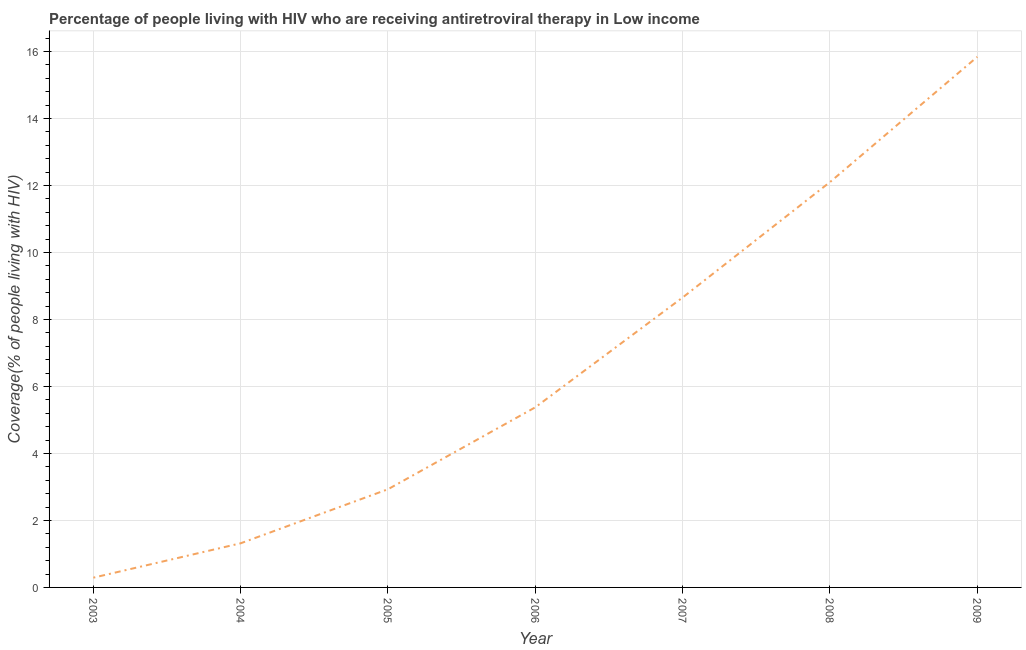What is the antiretroviral therapy coverage in 2003?
Provide a succinct answer. 0.29. Across all years, what is the maximum antiretroviral therapy coverage?
Provide a short and direct response. 15.84. Across all years, what is the minimum antiretroviral therapy coverage?
Keep it short and to the point. 0.29. In which year was the antiretroviral therapy coverage maximum?
Offer a terse response. 2009. In which year was the antiretroviral therapy coverage minimum?
Your answer should be very brief. 2003. What is the sum of the antiretroviral therapy coverage?
Offer a very short reply. 46.52. What is the difference between the antiretroviral therapy coverage in 2003 and 2008?
Your response must be concise. -11.81. What is the average antiretroviral therapy coverage per year?
Your answer should be compact. 6.65. What is the median antiretroviral therapy coverage?
Your answer should be very brief. 5.38. In how many years, is the antiretroviral therapy coverage greater than 4.4 %?
Give a very brief answer. 4. Do a majority of the years between 2005 and 2008 (inclusive) have antiretroviral therapy coverage greater than 3.6 %?
Make the answer very short. Yes. What is the ratio of the antiretroviral therapy coverage in 2003 to that in 2008?
Make the answer very short. 0.02. What is the difference between the highest and the second highest antiretroviral therapy coverage?
Offer a terse response. 3.74. Is the sum of the antiretroviral therapy coverage in 2006 and 2007 greater than the maximum antiretroviral therapy coverage across all years?
Your answer should be very brief. No. What is the difference between the highest and the lowest antiretroviral therapy coverage?
Provide a short and direct response. 15.55. In how many years, is the antiretroviral therapy coverage greater than the average antiretroviral therapy coverage taken over all years?
Ensure brevity in your answer.  3. How many lines are there?
Make the answer very short. 1. How many years are there in the graph?
Give a very brief answer. 7. What is the difference between two consecutive major ticks on the Y-axis?
Your answer should be very brief. 2. Are the values on the major ticks of Y-axis written in scientific E-notation?
Provide a short and direct response. No. Does the graph contain any zero values?
Provide a short and direct response. No. Does the graph contain grids?
Keep it short and to the point. Yes. What is the title of the graph?
Make the answer very short. Percentage of people living with HIV who are receiving antiretroviral therapy in Low income. What is the label or title of the Y-axis?
Offer a terse response. Coverage(% of people living with HIV). What is the Coverage(% of people living with HIV) of 2003?
Provide a short and direct response. 0.29. What is the Coverage(% of people living with HIV) in 2004?
Your response must be concise. 1.32. What is the Coverage(% of people living with HIV) of 2005?
Ensure brevity in your answer.  2.93. What is the Coverage(% of people living with HIV) of 2006?
Provide a short and direct response. 5.38. What is the Coverage(% of people living with HIV) in 2007?
Make the answer very short. 8.66. What is the Coverage(% of people living with HIV) in 2008?
Your answer should be compact. 12.1. What is the Coverage(% of people living with HIV) in 2009?
Your response must be concise. 15.84. What is the difference between the Coverage(% of people living with HIV) in 2003 and 2004?
Provide a short and direct response. -1.03. What is the difference between the Coverage(% of people living with HIV) in 2003 and 2005?
Your answer should be very brief. -2.64. What is the difference between the Coverage(% of people living with HIV) in 2003 and 2006?
Provide a succinct answer. -5.09. What is the difference between the Coverage(% of people living with HIV) in 2003 and 2007?
Provide a short and direct response. -8.37. What is the difference between the Coverage(% of people living with HIV) in 2003 and 2008?
Offer a very short reply. -11.81. What is the difference between the Coverage(% of people living with HIV) in 2003 and 2009?
Keep it short and to the point. -15.55. What is the difference between the Coverage(% of people living with HIV) in 2004 and 2005?
Offer a very short reply. -1.61. What is the difference between the Coverage(% of people living with HIV) in 2004 and 2006?
Give a very brief answer. -4.06. What is the difference between the Coverage(% of people living with HIV) in 2004 and 2007?
Offer a terse response. -7.34. What is the difference between the Coverage(% of people living with HIV) in 2004 and 2008?
Offer a very short reply. -10.78. What is the difference between the Coverage(% of people living with HIV) in 2004 and 2009?
Keep it short and to the point. -14.52. What is the difference between the Coverage(% of people living with HIV) in 2005 and 2006?
Offer a very short reply. -2.45. What is the difference between the Coverage(% of people living with HIV) in 2005 and 2007?
Your answer should be very brief. -5.73. What is the difference between the Coverage(% of people living with HIV) in 2005 and 2008?
Make the answer very short. -9.17. What is the difference between the Coverage(% of people living with HIV) in 2005 and 2009?
Offer a very short reply. -12.91. What is the difference between the Coverage(% of people living with HIV) in 2006 and 2007?
Your answer should be compact. -3.28. What is the difference between the Coverage(% of people living with HIV) in 2006 and 2008?
Provide a short and direct response. -6.72. What is the difference between the Coverage(% of people living with HIV) in 2006 and 2009?
Your answer should be compact. -10.46. What is the difference between the Coverage(% of people living with HIV) in 2007 and 2008?
Keep it short and to the point. -3.45. What is the difference between the Coverage(% of people living with HIV) in 2007 and 2009?
Your answer should be compact. -7.18. What is the difference between the Coverage(% of people living with HIV) in 2008 and 2009?
Your response must be concise. -3.74. What is the ratio of the Coverage(% of people living with HIV) in 2003 to that in 2004?
Make the answer very short. 0.22. What is the ratio of the Coverage(% of people living with HIV) in 2003 to that in 2005?
Your answer should be compact. 0.1. What is the ratio of the Coverage(% of people living with HIV) in 2003 to that in 2006?
Offer a very short reply. 0.05. What is the ratio of the Coverage(% of people living with HIV) in 2003 to that in 2007?
Give a very brief answer. 0.03. What is the ratio of the Coverage(% of people living with HIV) in 2003 to that in 2008?
Provide a succinct answer. 0.02. What is the ratio of the Coverage(% of people living with HIV) in 2003 to that in 2009?
Your response must be concise. 0.02. What is the ratio of the Coverage(% of people living with HIV) in 2004 to that in 2005?
Your answer should be very brief. 0.45. What is the ratio of the Coverage(% of people living with HIV) in 2004 to that in 2006?
Keep it short and to the point. 0.24. What is the ratio of the Coverage(% of people living with HIV) in 2004 to that in 2007?
Offer a very short reply. 0.15. What is the ratio of the Coverage(% of people living with HIV) in 2004 to that in 2008?
Give a very brief answer. 0.11. What is the ratio of the Coverage(% of people living with HIV) in 2004 to that in 2009?
Offer a very short reply. 0.08. What is the ratio of the Coverage(% of people living with HIV) in 2005 to that in 2006?
Your answer should be compact. 0.55. What is the ratio of the Coverage(% of people living with HIV) in 2005 to that in 2007?
Your answer should be very brief. 0.34. What is the ratio of the Coverage(% of people living with HIV) in 2005 to that in 2008?
Provide a short and direct response. 0.24. What is the ratio of the Coverage(% of people living with HIV) in 2005 to that in 2009?
Give a very brief answer. 0.18. What is the ratio of the Coverage(% of people living with HIV) in 2006 to that in 2007?
Offer a terse response. 0.62. What is the ratio of the Coverage(% of people living with HIV) in 2006 to that in 2008?
Offer a terse response. 0.44. What is the ratio of the Coverage(% of people living with HIV) in 2006 to that in 2009?
Your answer should be very brief. 0.34. What is the ratio of the Coverage(% of people living with HIV) in 2007 to that in 2008?
Your answer should be very brief. 0.71. What is the ratio of the Coverage(% of people living with HIV) in 2007 to that in 2009?
Provide a short and direct response. 0.55. What is the ratio of the Coverage(% of people living with HIV) in 2008 to that in 2009?
Offer a very short reply. 0.76. 